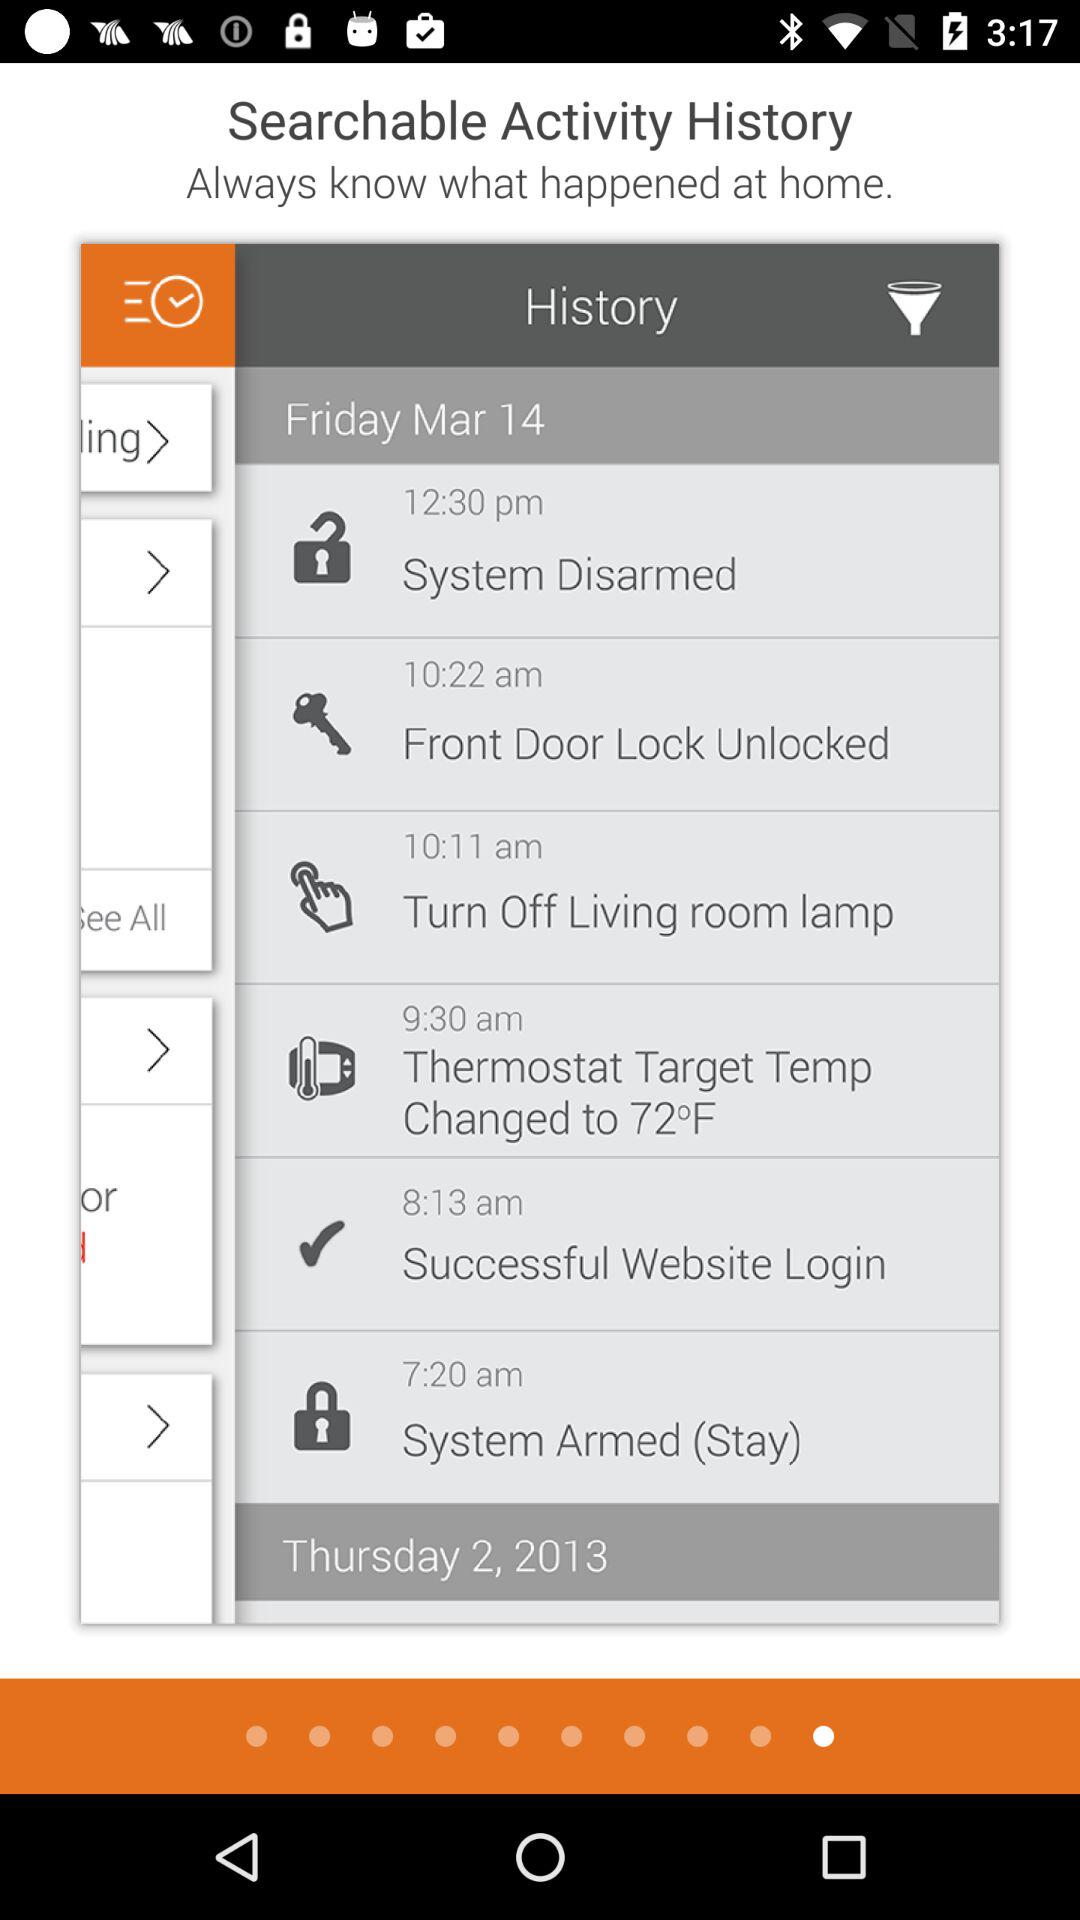What is the target temperature of the thermostat? The target temperature of the thermostat is 72 degrees Fahrenheit. 